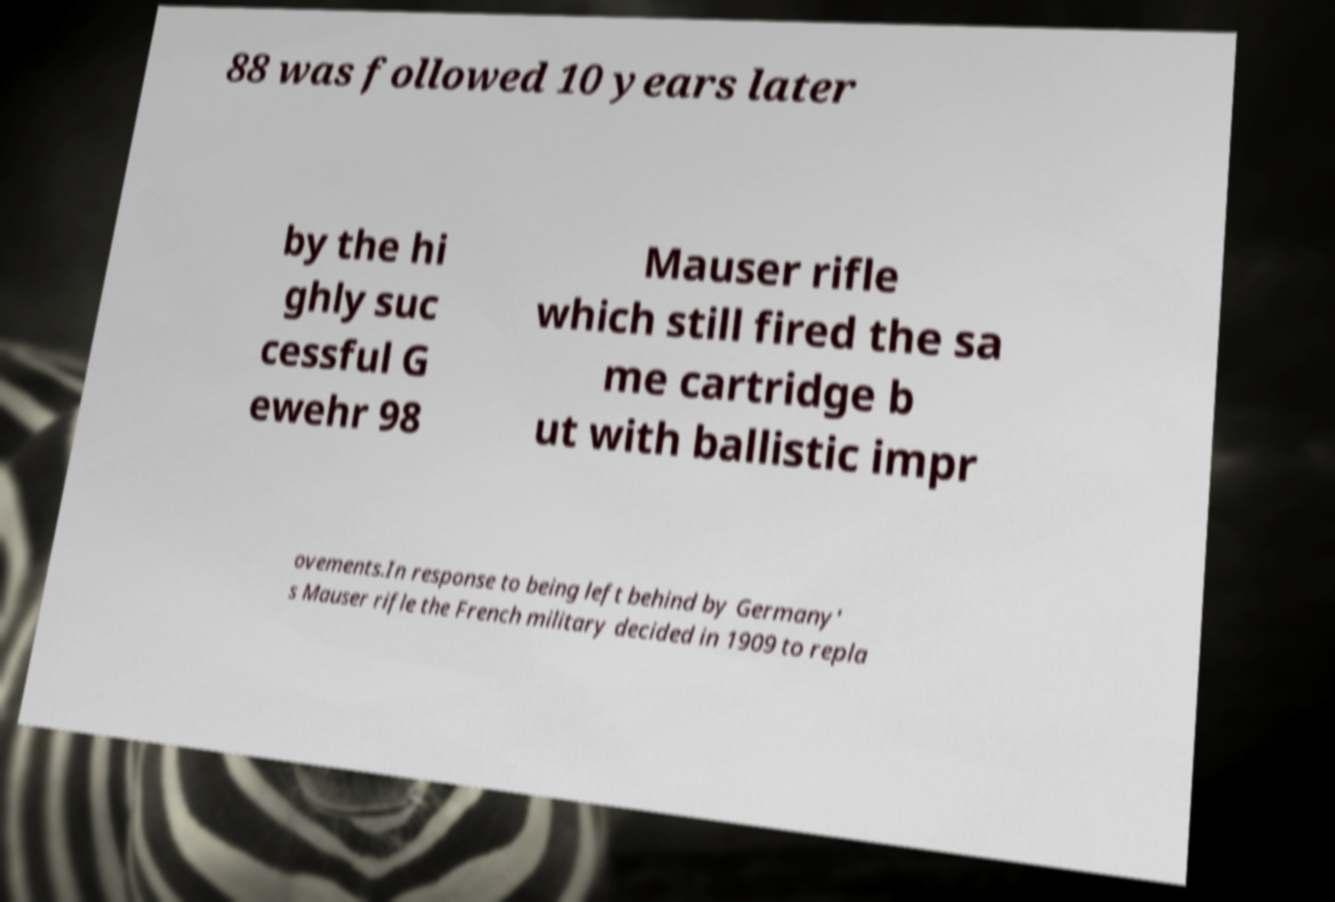I need the written content from this picture converted into text. Can you do that? 88 was followed 10 years later by the hi ghly suc cessful G ewehr 98 Mauser rifle which still fired the sa me cartridge b ut with ballistic impr ovements.In response to being left behind by Germany' s Mauser rifle the French military decided in 1909 to repla 